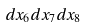<formula> <loc_0><loc_0><loc_500><loc_500>d x _ { 6 } d x _ { 7 } d x _ { 8 }</formula> 